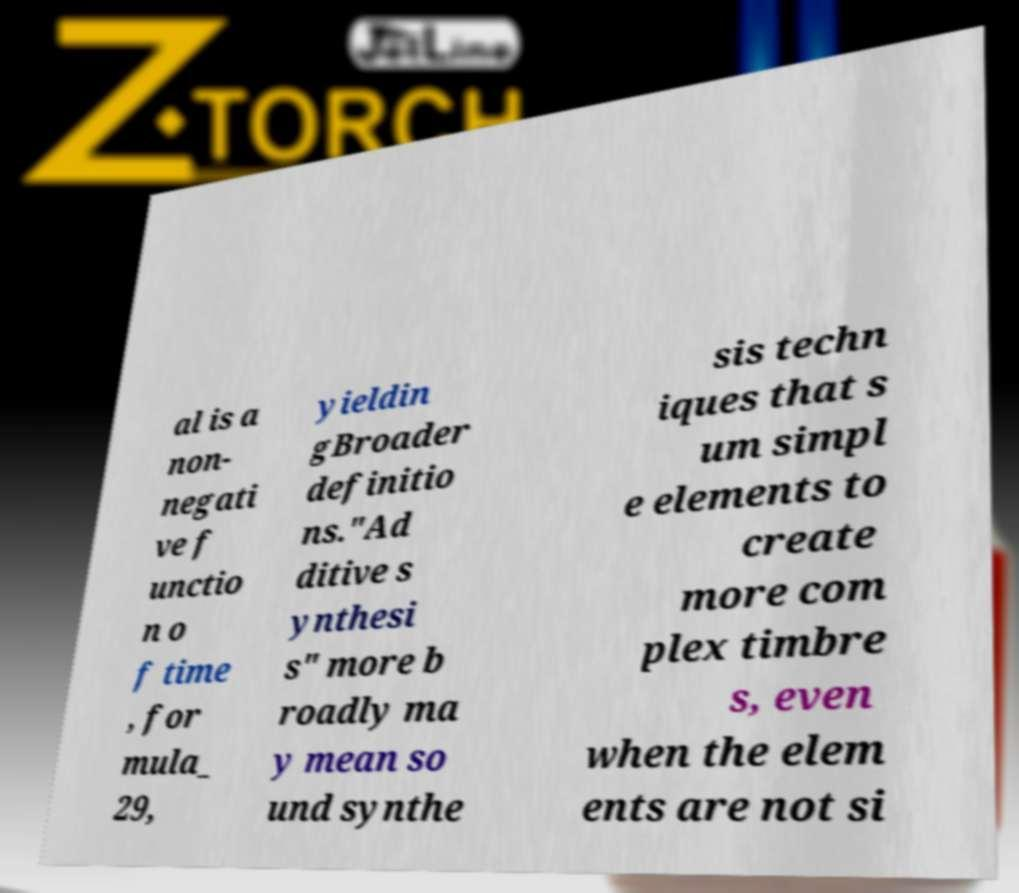I need the written content from this picture converted into text. Can you do that? al is a non- negati ve f unctio n o f time , for mula_ 29, yieldin gBroader definitio ns."Ad ditive s ynthesi s" more b roadly ma y mean so und synthe sis techn iques that s um simpl e elements to create more com plex timbre s, even when the elem ents are not si 